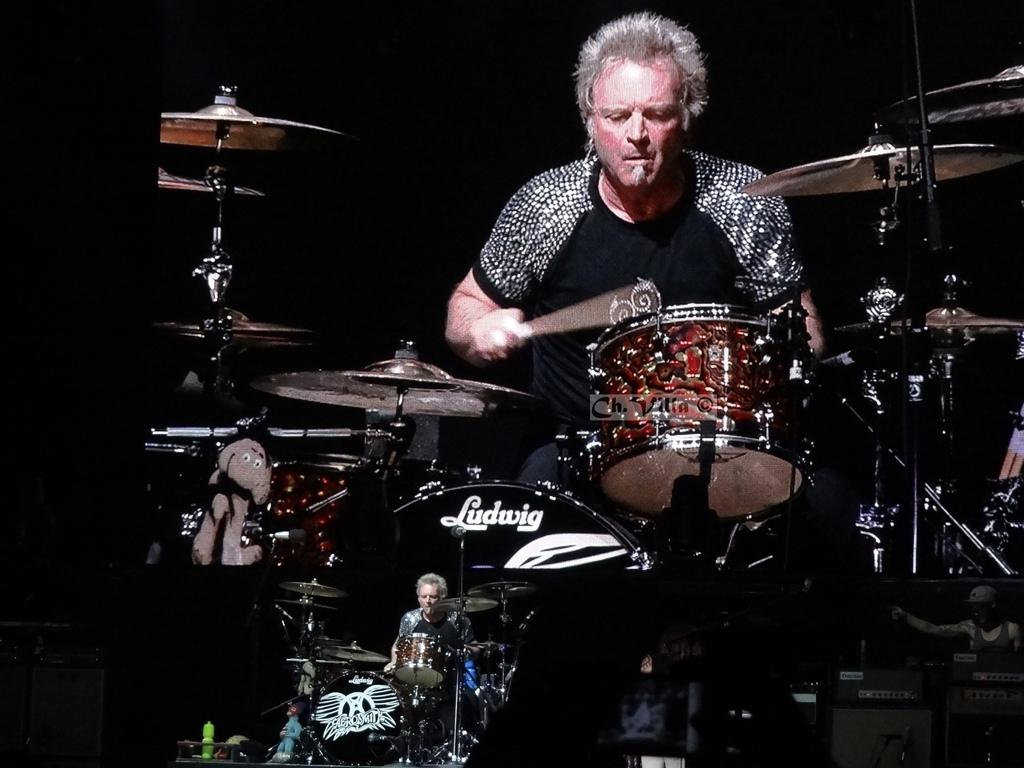What is the main activity being performed by the person in the image? There is a person playing drums in the image. What objects are present at the bottom of the image? There are television screens at the bottom of the image. What is being displayed on the television screens? The television screens display people playing drums. How would you describe the lighting in the image? The background of the image is dark. What type of lunch is being served at the seashore in the image? There is no mention of lunch or a seashore in the image; it features a person playing drums and television screens displaying drummers. 